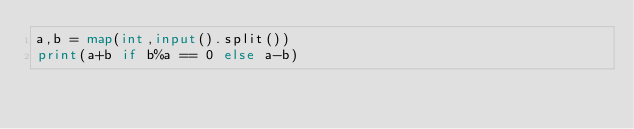Convert code to text. <code><loc_0><loc_0><loc_500><loc_500><_Python_>a,b = map(int,input().split())
print(a+b if b%a == 0 else a-b)
</code> 